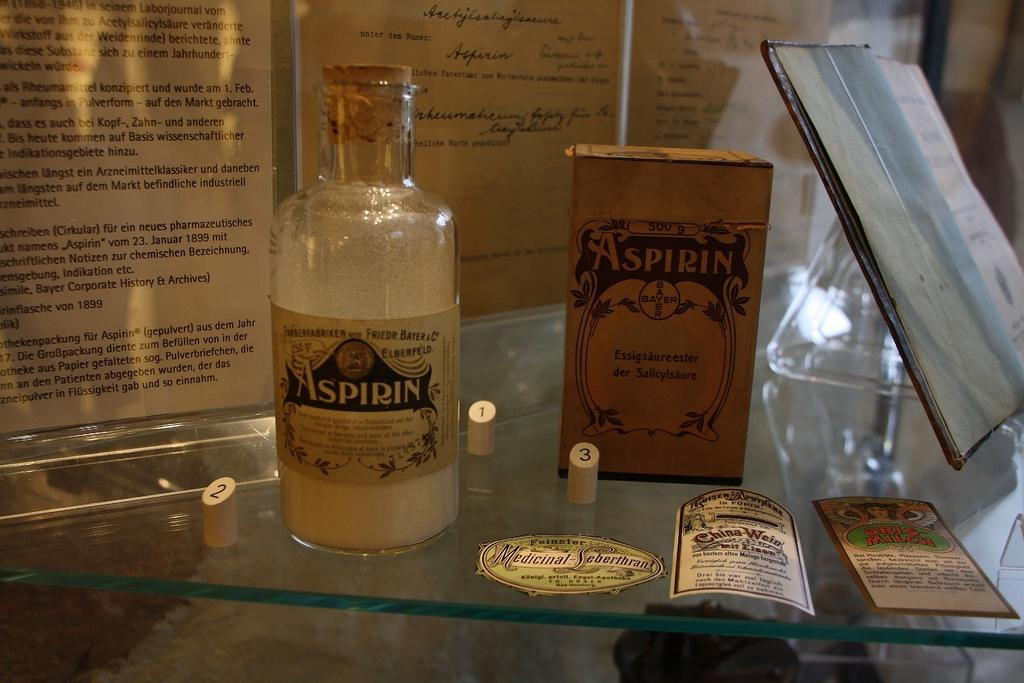<image>
Share a concise interpretation of the image provided. A display table featuring different medicines including Aspirin 